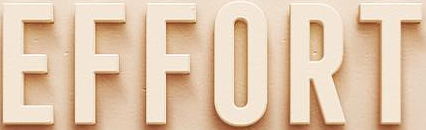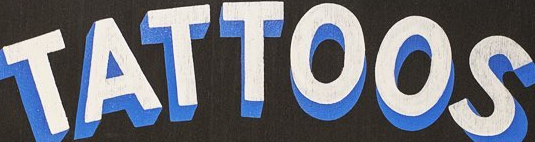Identify the words shown in these images in order, separated by a semicolon. EFFORT; TATTOOS 